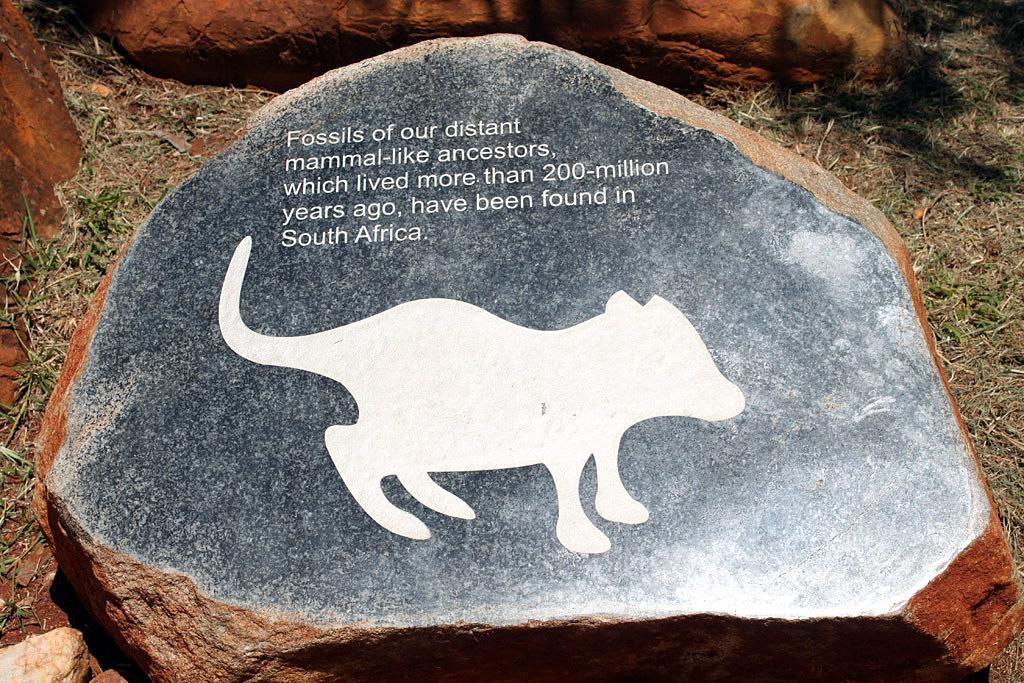Describe this image in one or two sentences. In this image we can see a stone. On this stone we can see picture of an animal and something is written on it. Here we can see grass and stones. 